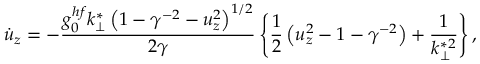Convert formula to latex. <formula><loc_0><loc_0><loc_500><loc_500>\dot { u } _ { z } = - \frac { g _ { 0 } ^ { h f } k _ { \perp } ^ { * } \left ( 1 - \gamma ^ { - 2 } - u _ { z } ^ { 2 } \right ) ^ { 1 / 2 } } { 2 \gamma } \left \{ \frac { 1 } { 2 } \left ( u _ { z } ^ { 2 } - 1 - \gamma ^ { - 2 } \right ) + \frac { 1 } { k _ { \perp } ^ { * 2 } } \right \} ,</formula> 